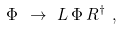<formula> <loc_0><loc_0><loc_500><loc_500>\Phi \ \rightarrow \ L \, \Phi \, R ^ { \dagger } \ ,</formula> 